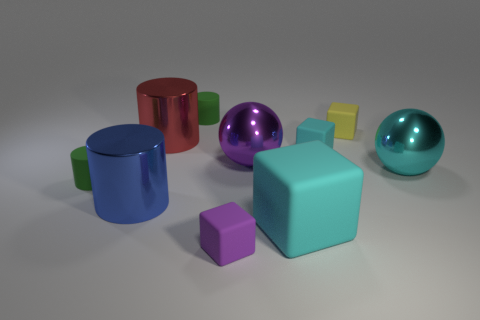There is a tiny thing that is the same color as the big matte thing; what is it made of?
Provide a succinct answer. Rubber. There is a purple sphere to the right of the green object that is behind the large purple thing; what is its material?
Offer a terse response. Metal. What material is the block that is the same size as the blue shiny object?
Your answer should be very brief. Rubber. Does the shiny cylinder that is on the left side of the red cylinder have the same size as the big red thing?
Offer a terse response. Yes. There is a tiny green thing to the left of the big red metallic object; is its shape the same as the big blue thing?
Ensure brevity in your answer.  Yes. How many things are big purple matte things or tiny matte things that are on the left side of the large cyan block?
Provide a short and direct response. 3. Are there fewer big cyan metallic things than cyan things?
Your response must be concise. Yes. Is the number of tiny yellow cubes greater than the number of small metallic spheres?
Provide a succinct answer. Yes. How many other things are made of the same material as the small yellow object?
Keep it short and to the point. 5. What number of large metal cylinders are in front of the small object that is in front of the small cylinder that is left of the blue shiny cylinder?
Your response must be concise. 0. 